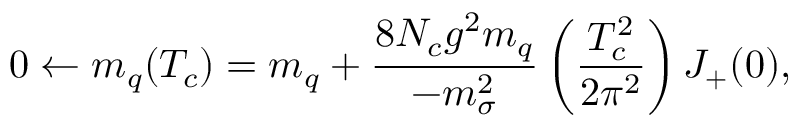<formula> <loc_0><loc_0><loc_500><loc_500>0 \leftarrow m _ { q } ( T _ { c } ) = m _ { q } + \frac { 8 N _ { c } g ^ { 2 } m _ { q } } { - m _ { \sigma } ^ { 2 } } \left ( \frac { T _ { c } ^ { 2 } } { 2 \pi ^ { 2 } } \right ) J _ { + } ( 0 ) ,</formula> 